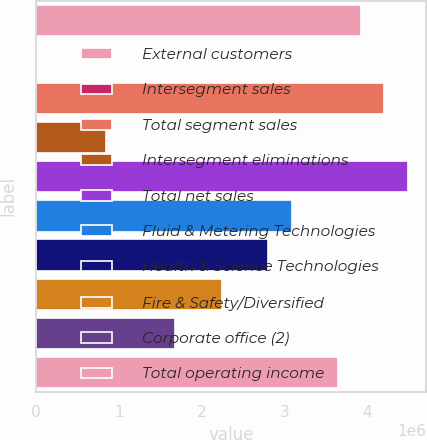Convert chart. <chart><loc_0><loc_0><loc_500><loc_500><bar_chart><fcel>External customers<fcel>Intersegment sales<fcel>Total segment sales<fcel>Intersegment eliminations<fcel>Total net sales<fcel>Fluid & Metering Technologies<fcel>Health & Science Technologies<fcel>Fire & Safety/Diversified<fcel>Corporate office (2)<fcel>Total operating income<nl><fcel>3.92728e+06<fcel>847<fcel>4.20774e+06<fcel>842226<fcel>4.4882e+06<fcel>3.0859e+06<fcel>2.80544e+06<fcel>2.24452e+06<fcel>1.6836e+06<fcel>3.64682e+06<nl></chart> 